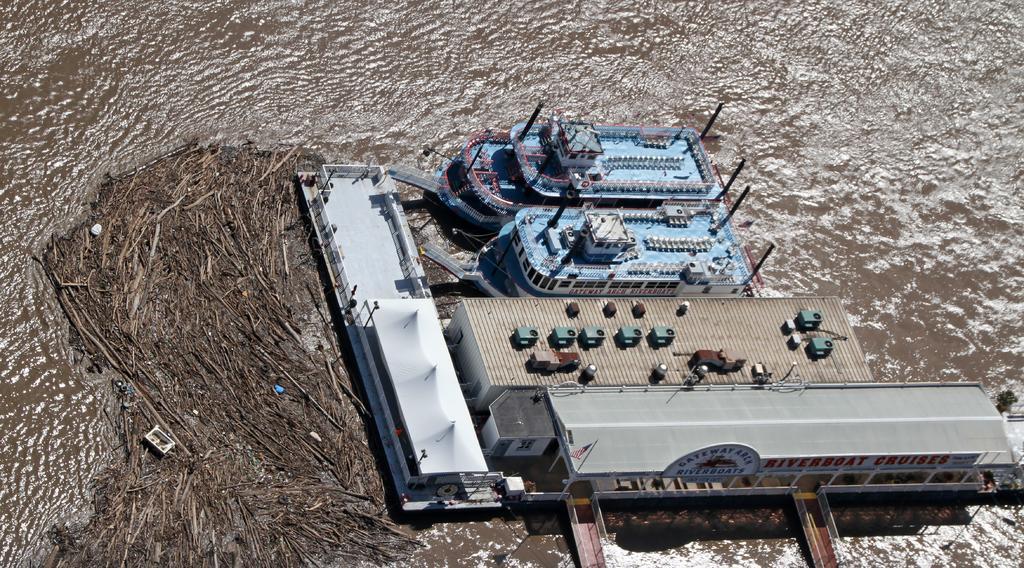How would you summarize this image in a sentence or two? In this picture we can observe a dock. There are blue color ships floating on the Water near the dock. We can observe water in the background. 